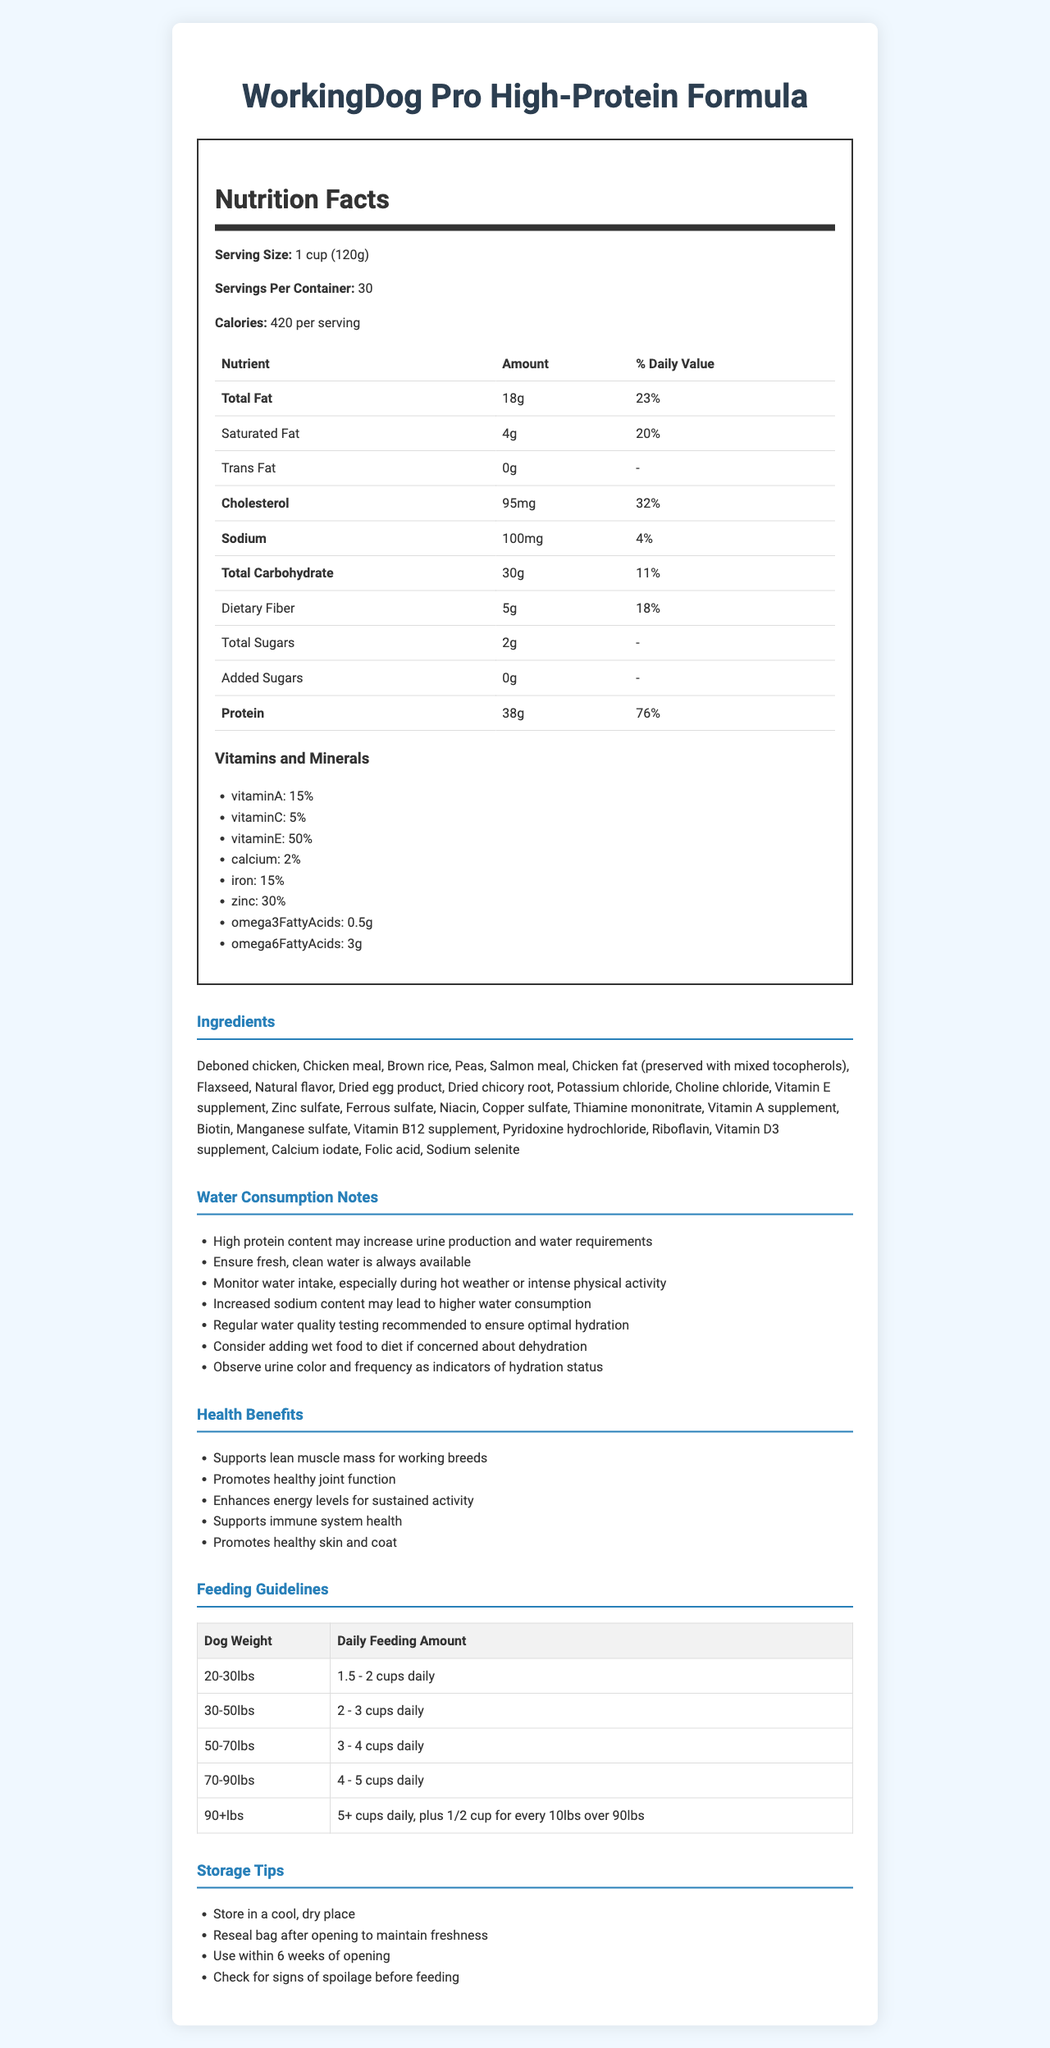what is the serving size of the WorkingDog Pro High-Protein Formula? The serving size is explicitly mentioned in the document under the Nutrition Facts section as "1 cup (120g)".
Answer: 1 cup (120g) how many calories are there per serving of the dog food? The document states in the Nutrition Facts section that each serving contains 420 calories.
Answer: 420 calories list two main ingredients in the dog food The ingredients list in the document starts with "Deboned chicken, Chicken meal", indicating these as the two main ingredients.
Answer: Deboned chicken, Chicken meal what percentage of the daily value of protein does each serving contain? The Nutrition Facts section specifies that the daily value percentage for protein per serving is 76%.
Answer: 76% how many servings are there per container? The document states in the Nutrition Facts section that there are 30 servings per container.
Answer: 30 servings which nutrient has the highest daily value percentage? The daily value percentages listed in the Nutrition Facts section show that protein has the highest at 76%.
Answer: Protein (76%) what should you ensure for your dog, according to the water consumption notes? A. Peaceful environment B. Fresh, clean water always available C. Regular exercise D. Balanced diet The Water Consumption Notes section advises ensuring "fresh, clean water is always available".
Answer: B what is the daily feeding amount for a dog weighing 50-70 lbs? A. 2 - 3 cups B. 3 - 4 cups C. 4 - 5 cups D. 5+ cups The Feeding Guidelines table lists the daily feeding amount for a dog weighing 50-70 lbs as 3 - 4 cups.
Answer: B does this dog food contain any added sugars? The Nutrition Facts section indicates "Added Sugars" as 0g.
Answer: No describe the main idea of the document The document contains various sections each detailing aspects such as nutritional content, key ingredients, benefits of the food, and guidelines for feeding and storing the dog food product.
Answer: The document provides detailed information about the WorkingDog Pro High-Protein Formula dog food, including its nutritional facts, ingredients, water consumption notes, health benefits, feeding guidelines, and storage tips. what is the source of Omega-3 fatty acids in this dog food? The document lists the amount of Omega-3 fatty acids but does not specify the specific source or ingredient that provides them.
Answer: Cannot be determined 